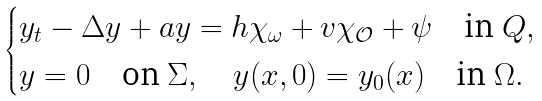<formula> <loc_0><loc_0><loc_500><loc_500>\begin{cases} y _ { t } - \Delta y + a y = h \chi _ { \omega } + v \chi _ { \mathcal { O } } + \psi \quad \text {in } Q , \\ y = 0 \quad \text {on } \Sigma , \quad y ( x , 0 ) = y _ { 0 } ( x ) \quad \text {in } \Omega . \end{cases}</formula> 